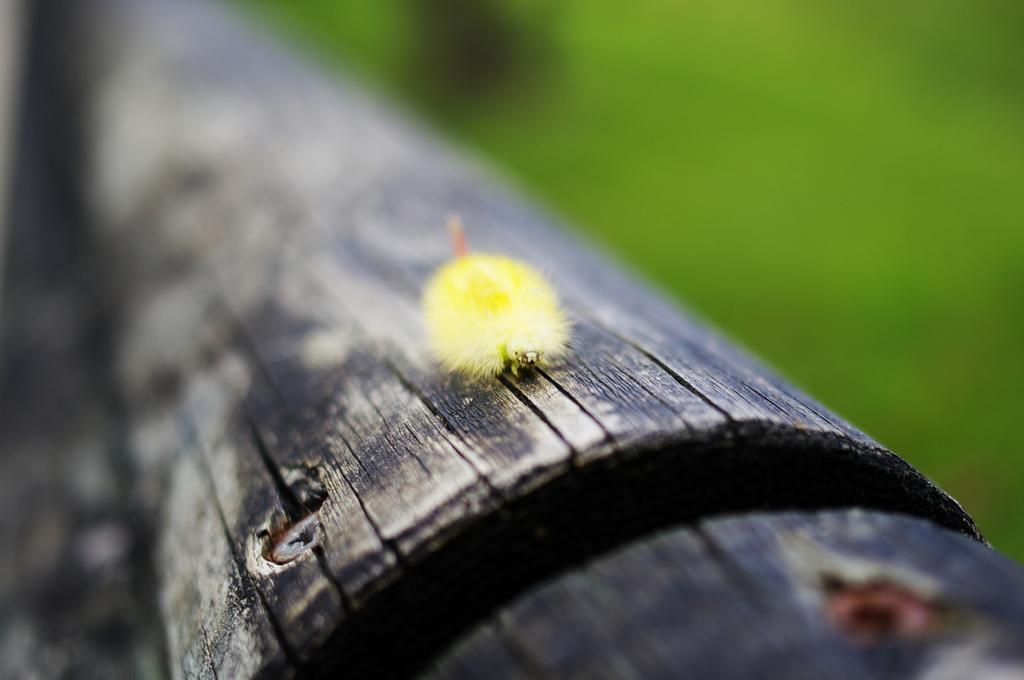What type of creature is present in the image? There is an insect in the image. Where is the insect located in the image? The insect is on a stem. What type of vegetable is the insect eating in the image? There is no vegetable present in the image, and the insect's actions are not described. 